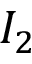<formula> <loc_0><loc_0><loc_500><loc_500>I _ { 2 }</formula> 